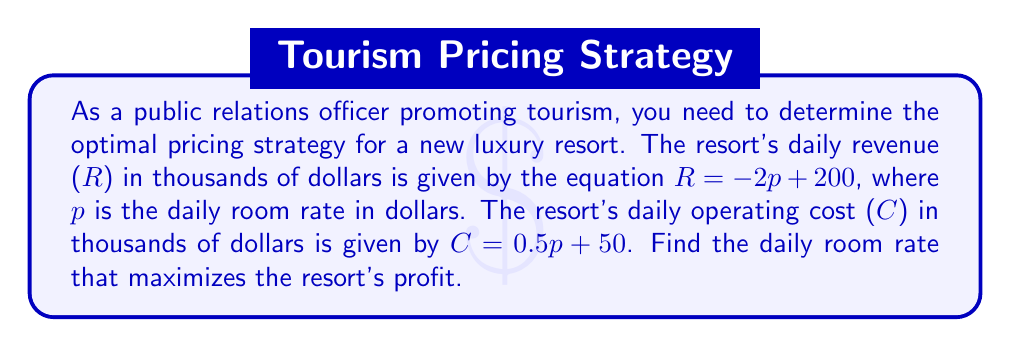Can you answer this question? 1. Define profit (P) as revenue minus cost:
   $P = R - C$

2. Substitute the given equations for R and C:
   $P = (-2p + 200) - (0.5p + 50)$

3. Simplify the equation:
   $P = -2p + 200 - 0.5p - 50$
   $P = -2.5p + 150$

4. To find the maximum profit, we need to find the vertex of this parabola. Since it's a linear equation, the maximum occurs at one of the endpoints of the domain.

5. The domain of p is restricted by two conditions:
   a) The price can't be negative: $p \geq 0$
   b) The revenue can't be negative: $-2p + 200 \geq 0$, so $p \leq 100$

6. Therefore, we need to compare the profit at $p = 0$ and $p = 100$:
   At $p = 0$: $P = -2.5(0) + 150 = 150$
   At $p = 100$: $P = -2.5(100) + 150 = -100$

7. The profit is maximized at $p = 0$, but this isn't a realistic price. We need to find the next best integer value.

8. Calculate profit for small integer values of p:
   At $p = 1$: $P = -2.5(1) + 150 = 147.5$
   At $p = 2$: $P = -2.5(2) + 150 = 145$

9. We can see that as p increases, profit decreases. Therefore, the optimal integer price is $p = 1$.
Answer: $1 (daily room rate in dollars) 